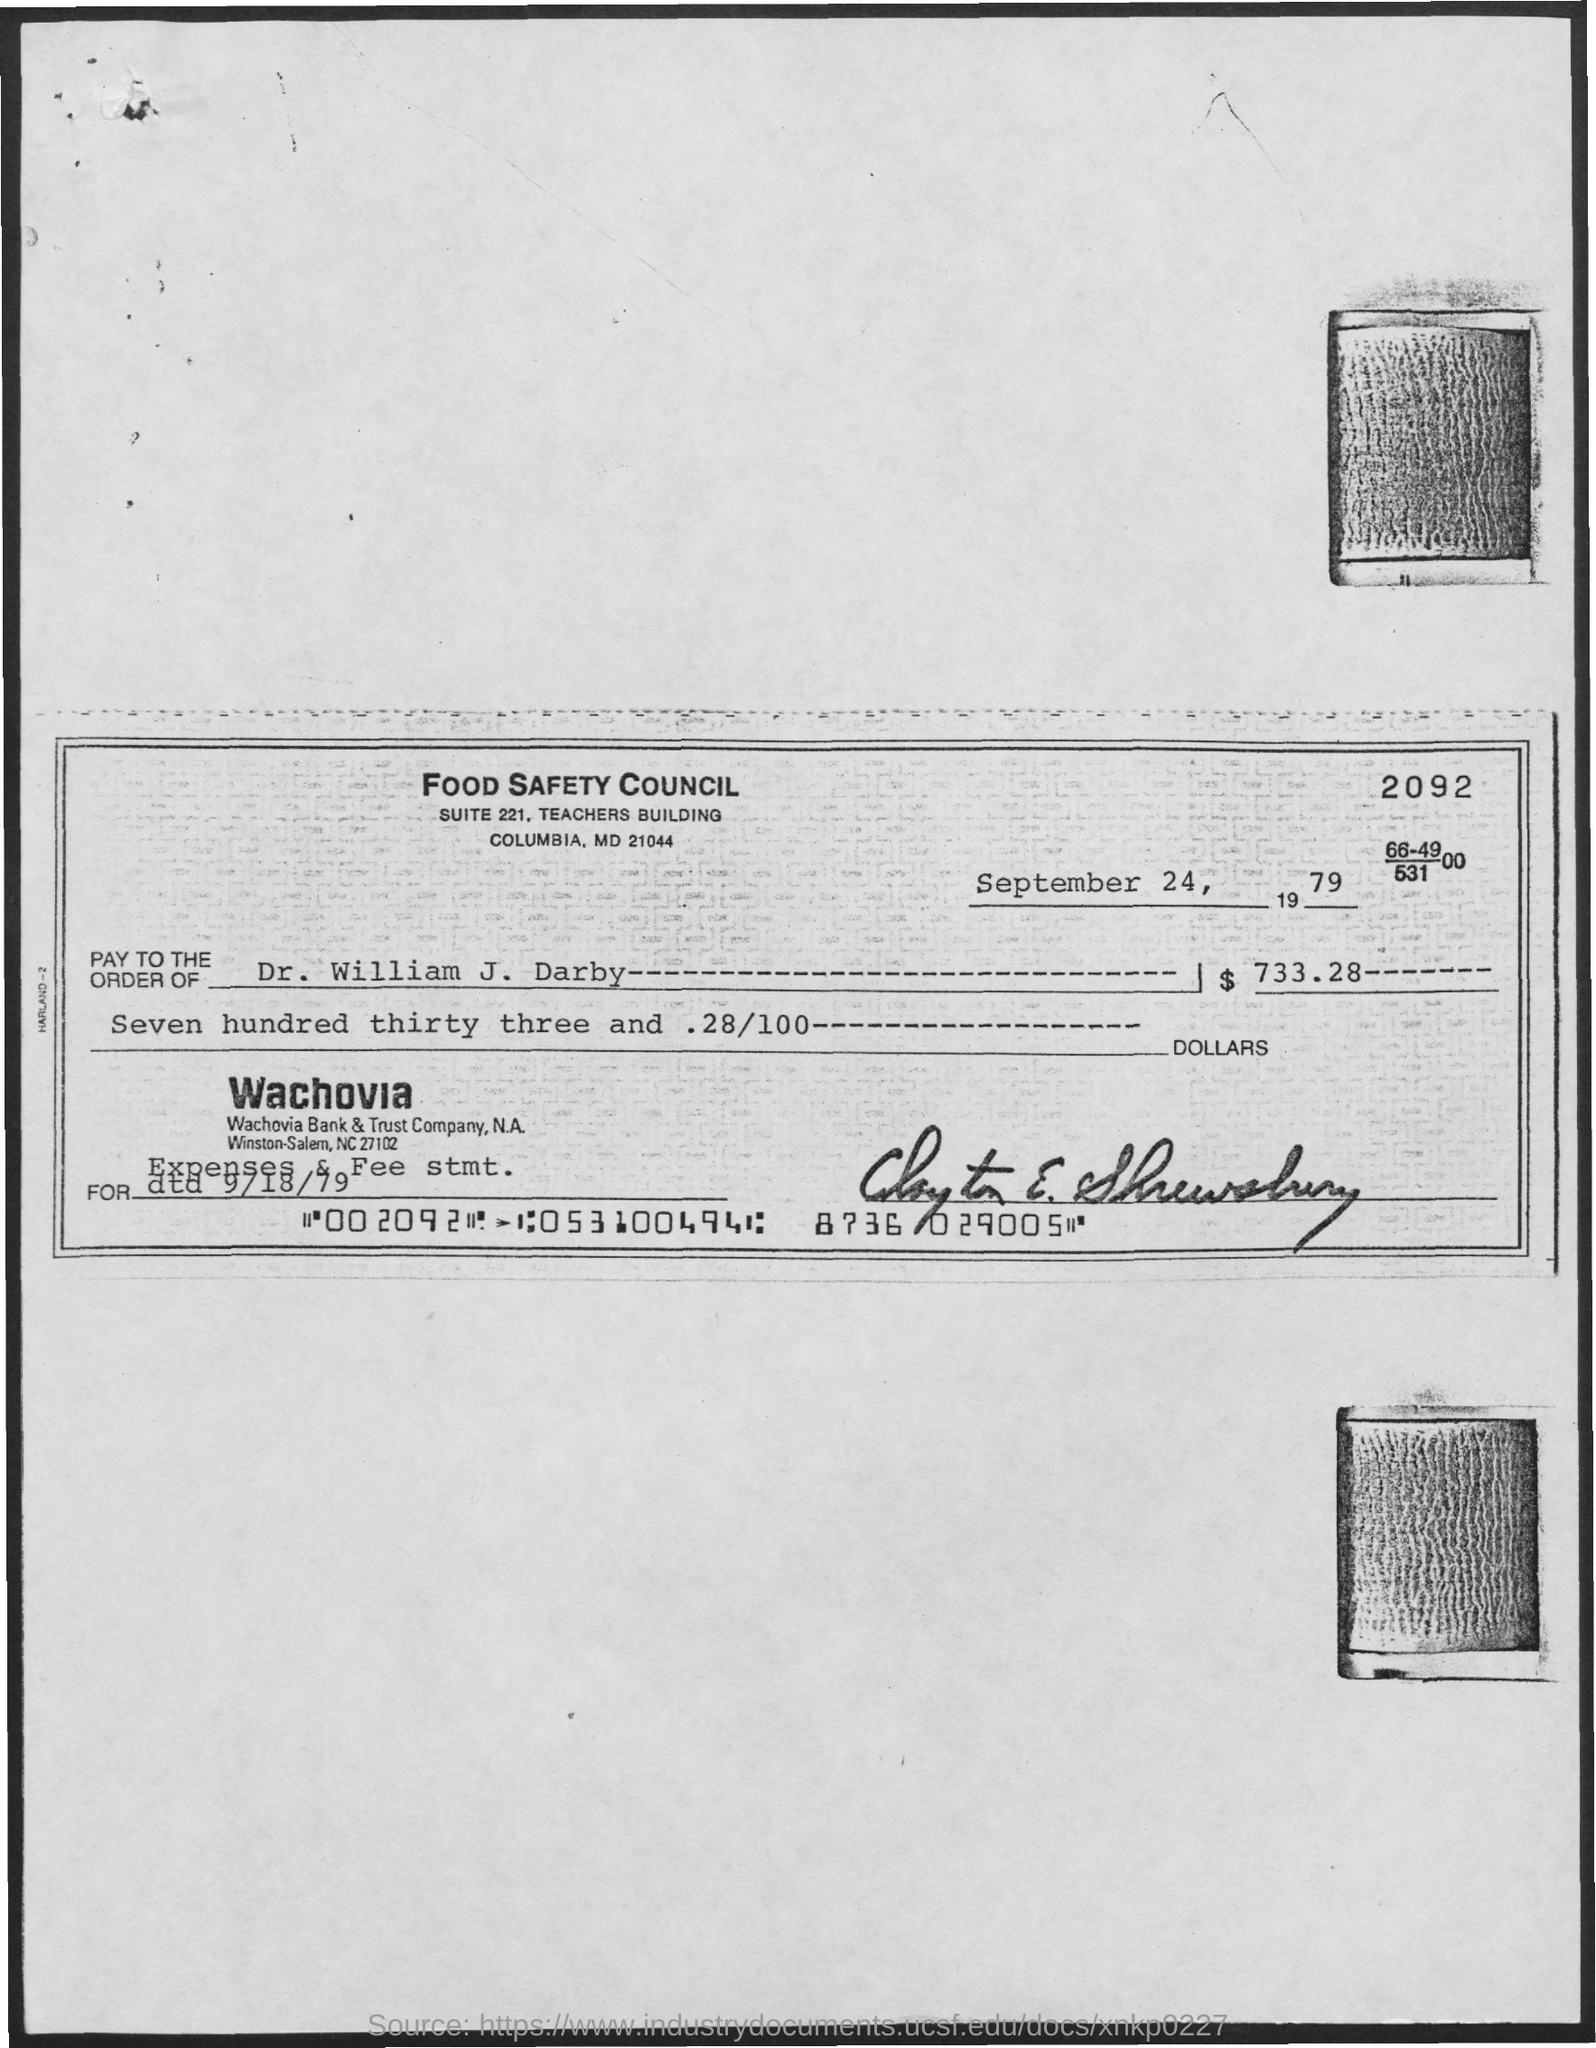What is the name of the council?
Your answer should be very brief. Food Safety Council. What is the address of food safety council?
Your answer should be very brief. Suite 221, Teachers Building Columbia, MD 21044. Who is the receiver of the cheque?
Ensure brevity in your answer.  Dr. William J. Darby. What is the amount in the cheque?
Provide a short and direct response. $733.28. On which date is the cheque issued?
Make the answer very short. SEPTEMBER 24, 1979. 